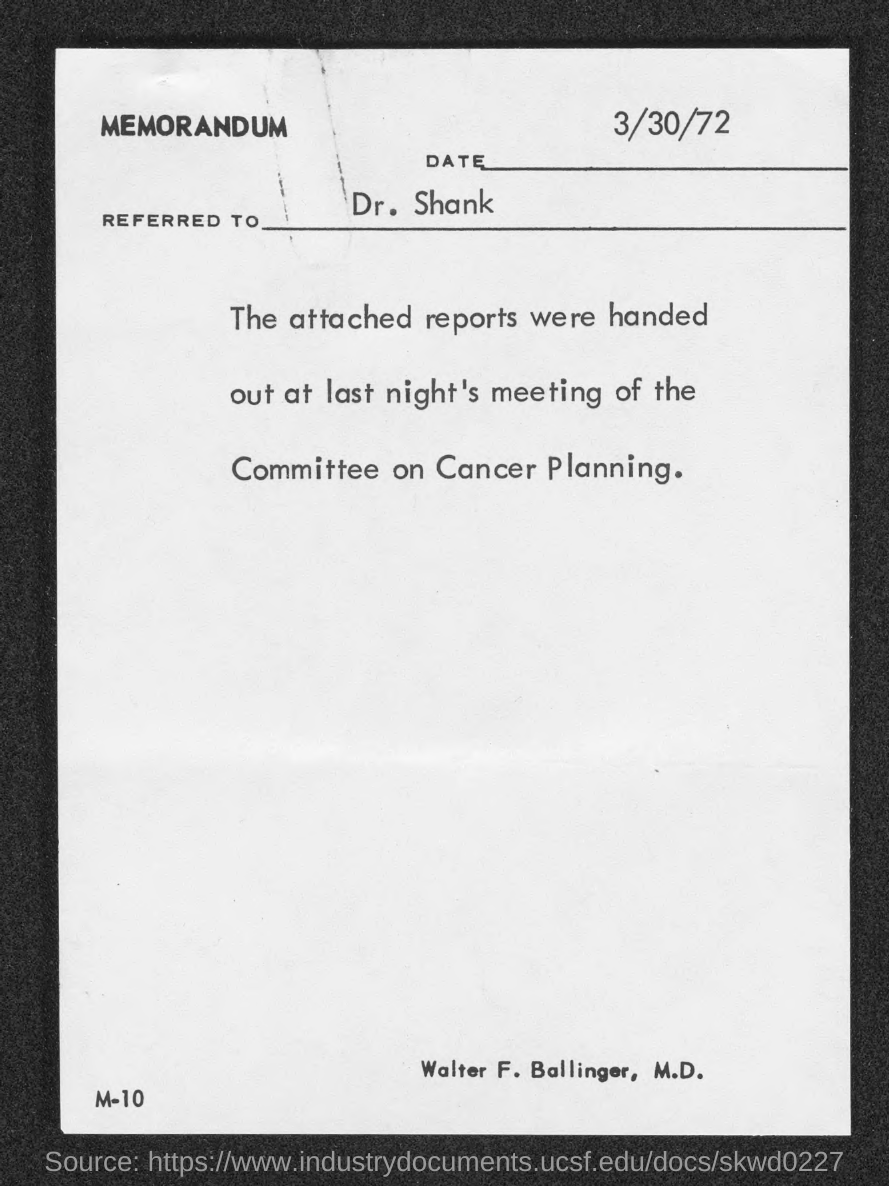What is the date mentioned in the memorandum?
Make the answer very short. 3/30/72. To whom, the memorandum is addressed?
Ensure brevity in your answer.  Dr. shank. 